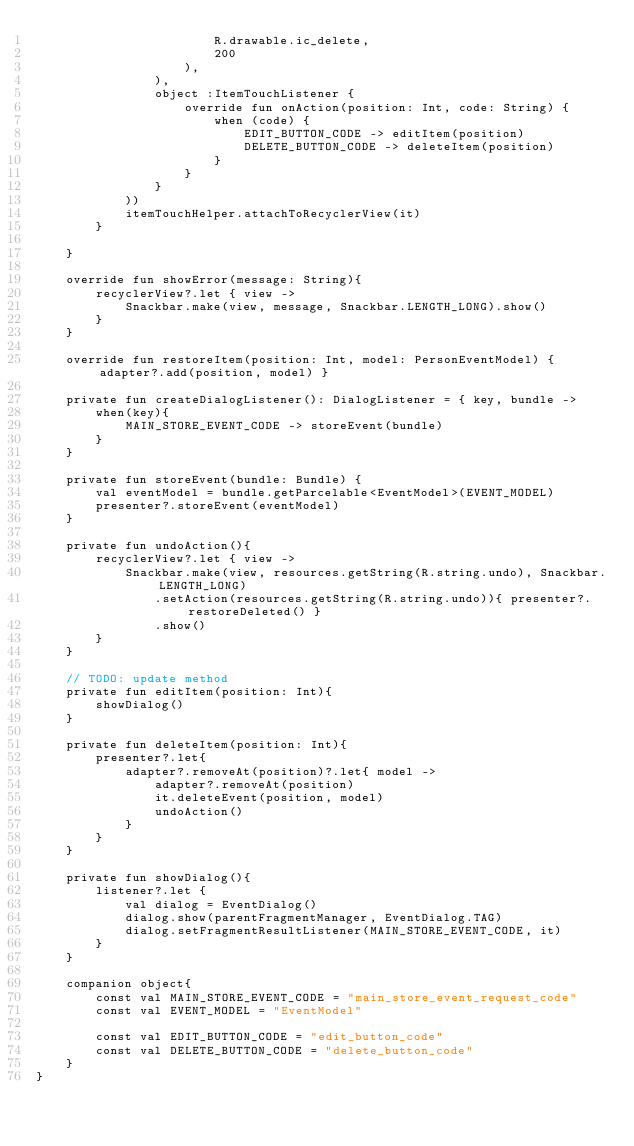<code> <loc_0><loc_0><loc_500><loc_500><_Kotlin_>                        R.drawable.ic_delete,
                        200
                    ),
                ),
                object :ItemTouchListener {
                    override fun onAction(position: Int, code: String) {
                        when (code) {
                            EDIT_BUTTON_CODE -> editItem(position)
                            DELETE_BUTTON_CODE -> deleteItem(position)
                        }
                    }
                }
            ))
            itemTouchHelper.attachToRecyclerView(it)
        }

    }

    override fun showError(message: String){
        recyclerView?.let { view ->
            Snackbar.make(view, message, Snackbar.LENGTH_LONG).show()
        }
    }

    override fun restoreItem(position: Int, model: PersonEventModel) { adapter?.add(position, model) }

    private fun createDialogListener(): DialogListener = { key, bundle ->
        when(key){
            MAIN_STORE_EVENT_CODE -> storeEvent(bundle)
        }
    }

    private fun storeEvent(bundle: Bundle) {
        val eventModel = bundle.getParcelable<EventModel>(EVENT_MODEL)
        presenter?.storeEvent(eventModel)
    }

    private fun undoAction(){
        recyclerView?.let { view ->
            Snackbar.make(view, resources.getString(R.string.undo), Snackbar.LENGTH_LONG)
                .setAction(resources.getString(R.string.undo)){ presenter?.restoreDeleted() }
                .show()
        }
    }

    // TODO: update method
    private fun editItem(position: Int){
        showDialog()
    }

    private fun deleteItem(position: Int){
        presenter?.let{
            adapter?.removeAt(position)?.let{ model ->
                adapter?.removeAt(position)
                it.deleteEvent(position, model)
                undoAction()
            }
        }
    }

    private fun showDialog(){
        listener?.let {
            val dialog = EventDialog()
            dialog.show(parentFragmentManager, EventDialog.TAG)
            dialog.setFragmentResultListener(MAIN_STORE_EVENT_CODE, it)
        }
    }

    companion object{
        const val MAIN_STORE_EVENT_CODE = "main_store_event_request_code"
        const val EVENT_MODEL = "EventModel"

        const val EDIT_BUTTON_CODE = "edit_button_code"
        const val DELETE_BUTTON_CODE = "delete_button_code"
    }
}</code> 